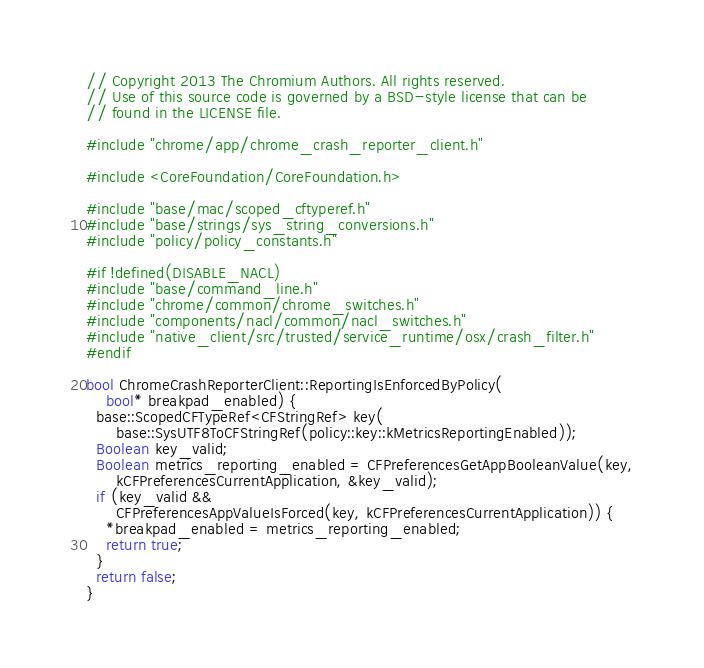Convert code to text. <code><loc_0><loc_0><loc_500><loc_500><_ObjectiveC_>// Copyright 2013 The Chromium Authors. All rights reserved.
// Use of this source code is governed by a BSD-style license that can be
// found in the LICENSE file.

#include "chrome/app/chrome_crash_reporter_client.h"

#include <CoreFoundation/CoreFoundation.h>

#include "base/mac/scoped_cftyperef.h"
#include "base/strings/sys_string_conversions.h"
#include "policy/policy_constants.h"

#if !defined(DISABLE_NACL)
#include "base/command_line.h"
#include "chrome/common/chrome_switches.h"
#include "components/nacl/common/nacl_switches.h"
#include "native_client/src/trusted/service_runtime/osx/crash_filter.h"
#endif

bool ChromeCrashReporterClient::ReportingIsEnforcedByPolicy(
    bool* breakpad_enabled) {
  base::ScopedCFTypeRef<CFStringRef> key(
      base::SysUTF8ToCFStringRef(policy::key::kMetricsReportingEnabled));
  Boolean key_valid;
  Boolean metrics_reporting_enabled = CFPreferencesGetAppBooleanValue(key,
      kCFPreferencesCurrentApplication, &key_valid);
  if (key_valid &&
      CFPreferencesAppValueIsForced(key, kCFPreferencesCurrentApplication)) {
    *breakpad_enabled = metrics_reporting_enabled;
    return true;
  }
  return false;
}
</code> 